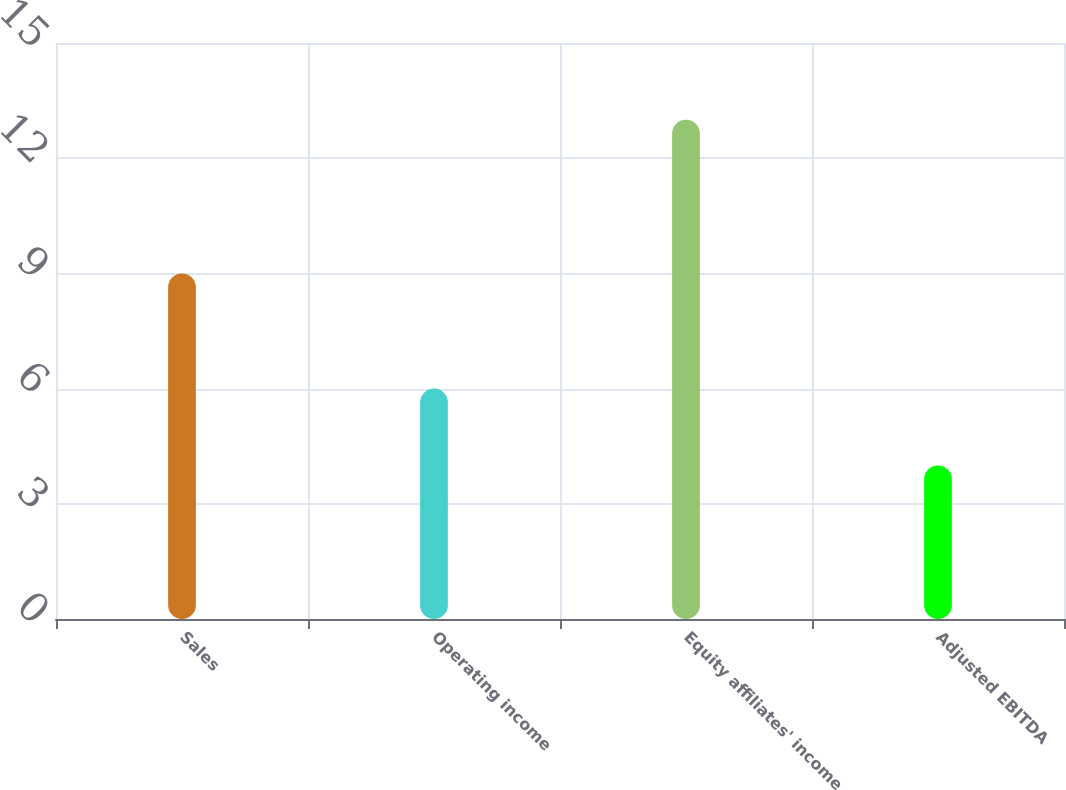Convert chart to OTSL. <chart><loc_0><loc_0><loc_500><loc_500><bar_chart><fcel>Sales<fcel>Operating income<fcel>Equity affiliates' income<fcel>Adjusted EBITDA<nl><fcel>9<fcel>6<fcel>13<fcel>4<nl></chart> 